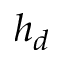<formula> <loc_0><loc_0><loc_500><loc_500>h _ { d }</formula> 